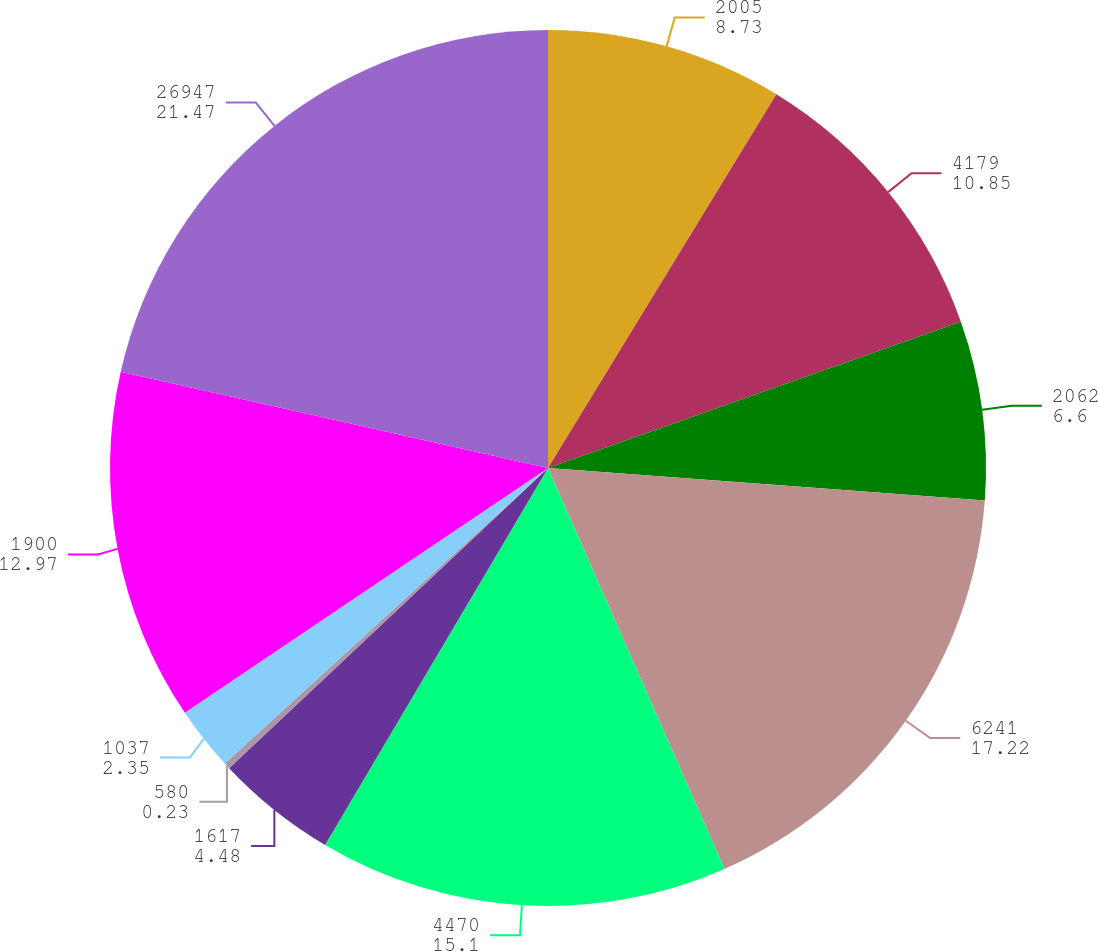Convert chart. <chart><loc_0><loc_0><loc_500><loc_500><pie_chart><fcel>2005<fcel>4179<fcel>2062<fcel>6241<fcel>4470<fcel>1617<fcel>580<fcel>1037<fcel>1900<fcel>26947<nl><fcel>8.73%<fcel>10.85%<fcel>6.6%<fcel>17.22%<fcel>15.1%<fcel>4.48%<fcel>0.23%<fcel>2.35%<fcel>12.97%<fcel>21.47%<nl></chart> 